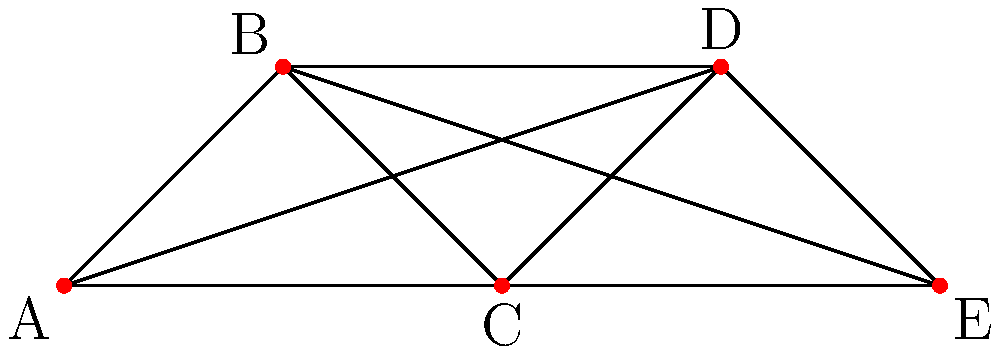Sam Dickinson's merchandise is sold in five different stores represented by the vertices A, B, C, D, and E in the graph. To optimize inventory management, Sam wants to assign one of three colors to each store such that no two adjacent stores (connected by an edge) have the same color. This allows for efficient restocking routes. What is the minimum number of colors needed to achieve this coloring scheme? To solve this graph coloring problem, we'll follow these steps:

1. Understand the graph:
   - The graph has 5 vertices (A, B, C, D, E) representing stores.
   - Each vertex is connected to every other vertex, forming a complete graph $K_5$.

2. Recall the chromatic number theorem:
   - For a complete graph $K_n$, the chromatic number $\chi(K_n) = n$.

3. Apply the theorem to our case:
   - We have $K_5$, so $\chi(K_5) = 5$.

4. Consider Sam's constraint:
   - Sam wants to use only three colors.

5. Analyze the feasibility:
   - Since $\chi(K_5) = 5$, it's impossible to color the graph with fewer than 5 colors while ensuring no adjacent vertices have the same color.
   - Therefore, Sam's constraint of using only three colors cannot be met.

6. Determine the minimum number of colors:
   - The minimum number of colors needed is equal to the chromatic number, which is 5.

Thus, the minimum number of colors needed to achieve the desired coloring scheme is 5, not the 3 that Sam initially wanted.
Answer: 5 colors 